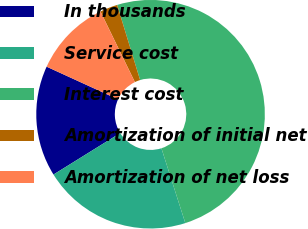Convert chart. <chart><loc_0><loc_0><loc_500><loc_500><pie_chart><fcel>In thousands<fcel>Service cost<fcel>Interest cost<fcel>Amortization of initial net<fcel>Amortization of net loss<nl><fcel>15.68%<fcel>21.07%<fcel>49.81%<fcel>2.5%<fcel>10.95%<nl></chart> 